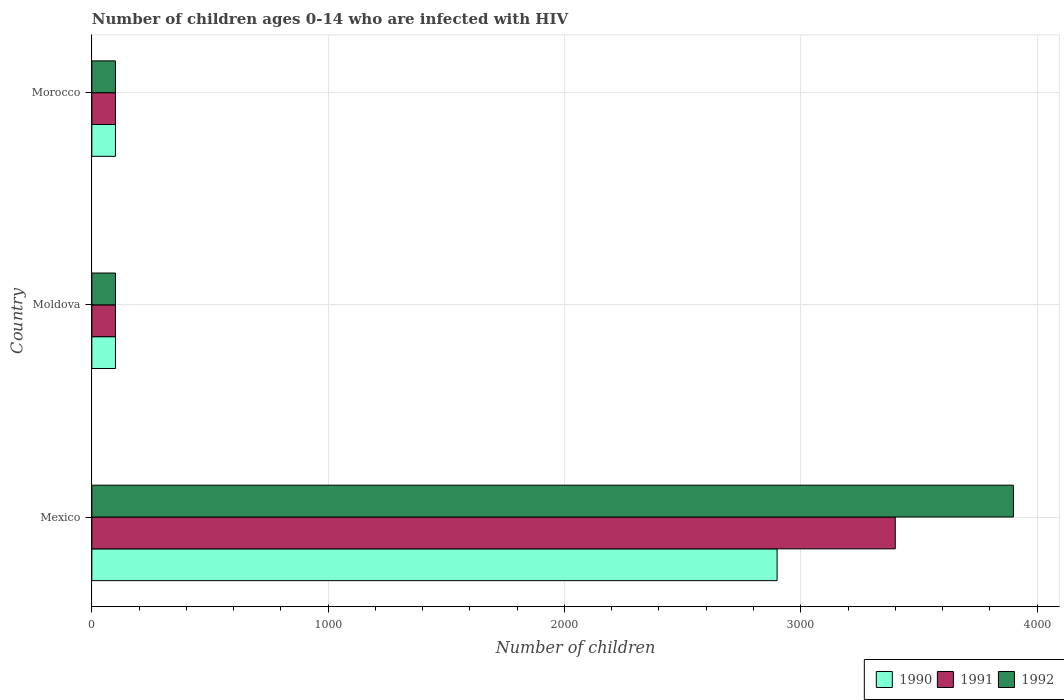How many different coloured bars are there?
Offer a terse response. 3. How many groups of bars are there?
Offer a very short reply. 3. Are the number of bars on each tick of the Y-axis equal?
Make the answer very short. Yes. How many bars are there on the 3rd tick from the top?
Give a very brief answer. 3. In how many cases, is the number of bars for a given country not equal to the number of legend labels?
Provide a short and direct response. 0. What is the number of HIV infected children in 1992 in Morocco?
Offer a terse response. 100. Across all countries, what is the maximum number of HIV infected children in 1991?
Offer a very short reply. 3400. Across all countries, what is the minimum number of HIV infected children in 1991?
Your response must be concise. 100. In which country was the number of HIV infected children in 1992 maximum?
Your answer should be very brief. Mexico. In which country was the number of HIV infected children in 1990 minimum?
Keep it short and to the point. Moldova. What is the total number of HIV infected children in 1991 in the graph?
Your answer should be very brief. 3600. What is the difference between the number of HIV infected children in 1992 in Mexico and that in Moldova?
Offer a very short reply. 3800. What is the difference between the number of HIV infected children in 1990 in Morocco and the number of HIV infected children in 1992 in Mexico?
Offer a terse response. -3800. What is the average number of HIV infected children in 1990 per country?
Provide a short and direct response. 1033.33. What is the difference between the number of HIV infected children in 1992 and number of HIV infected children in 1991 in Mexico?
Your answer should be compact. 500. In how many countries, is the number of HIV infected children in 1992 greater than 2400 ?
Your answer should be compact. 1. Is the number of HIV infected children in 1990 in Mexico less than that in Moldova?
Offer a terse response. No. What is the difference between the highest and the second highest number of HIV infected children in 1990?
Your answer should be compact. 2800. What is the difference between the highest and the lowest number of HIV infected children in 1990?
Offer a very short reply. 2800. What does the 2nd bar from the bottom in Moldova represents?
Your answer should be compact. 1991. Where does the legend appear in the graph?
Provide a short and direct response. Bottom right. How are the legend labels stacked?
Provide a short and direct response. Horizontal. What is the title of the graph?
Provide a short and direct response. Number of children ages 0-14 who are infected with HIV. What is the label or title of the X-axis?
Provide a short and direct response. Number of children. What is the label or title of the Y-axis?
Provide a short and direct response. Country. What is the Number of children of 1990 in Mexico?
Your response must be concise. 2900. What is the Number of children of 1991 in Mexico?
Offer a terse response. 3400. What is the Number of children in 1992 in Mexico?
Keep it short and to the point. 3900. What is the Number of children of 1990 in Moldova?
Offer a terse response. 100. What is the Number of children of 1991 in Moldova?
Offer a terse response. 100. What is the Number of children of 1992 in Moldova?
Give a very brief answer. 100. What is the Number of children in 1990 in Morocco?
Your response must be concise. 100. What is the Number of children in 1992 in Morocco?
Give a very brief answer. 100. Across all countries, what is the maximum Number of children in 1990?
Your answer should be very brief. 2900. Across all countries, what is the maximum Number of children of 1991?
Give a very brief answer. 3400. Across all countries, what is the maximum Number of children in 1992?
Provide a succinct answer. 3900. Across all countries, what is the minimum Number of children in 1990?
Provide a succinct answer. 100. Across all countries, what is the minimum Number of children in 1991?
Make the answer very short. 100. Across all countries, what is the minimum Number of children in 1992?
Offer a terse response. 100. What is the total Number of children of 1990 in the graph?
Make the answer very short. 3100. What is the total Number of children in 1991 in the graph?
Your answer should be compact. 3600. What is the total Number of children in 1992 in the graph?
Your answer should be compact. 4100. What is the difference between the Number of children in 1990 in Mexico and that in Moldova?
Provide a succinct answer. 2800. What is the difference between the Number of children in 1991 in Mexico and that in Moldova?
Keep it short and to the point. 3300. What is the difference between the Number of children in 1992 in Mexico and that in Moldova?
Your answer should be very brief. 3800. What is the difference between the Number of children of 1990 in Mexico and that in Morocco?
Provide a short and direct response. 2800. What is the difference between the Number of children of 1991 in Mexico and that in Morocco?
Make the answer very short. 3300. What is the difference between the Number of children of 1992 in Mexico and that in Morocco?
Provide a short and direct response. 3800. What is the difference between the Number of children of 1991 in Moldova and that in Morocco?
Offer a terse response. 0. What is the difference between the Number of children in 1992 in Moldova and that in Morocco?
Give a very brief answer. 0. What is the difference between the Number of children in 1990 in Mexico and the Number of children in 1991 in Moldova?
Your answer should be very brief. 2800. What is the difference between the Number of children in 1990 in Mexico and the Number of children in 1992 in Moldova?
Ensure brevity in your answer.  2800. What is the difference between the Number of children of 1991 in Mexico and the Number of children of 1992 in Moldova?
Give a very brief answer. 3300. What is the difference between the Number of children in 1990 in Mexico and the Number of children in 1991 in Morocco?
Offer a very short reply. 2800. What is the difference between the Number of children of 1990 in Mexico and the Number of children of 1992 in Morocco?
Ensure brevity in your answer.  2800. What is the difference between the Number of children of 1991 in Mexico and the Number of children of 1992 in Morocco?
Keep it short and to the point. 3300. What is the difference between the Number of children of 1991 in Moldova and the Number of children of 1992 in Morocco?
Give a very brief answer. 0. What is the average Number of children of 1990 per country?
Offer a very short reply. 1033.33. What is the average Number of children of 1991 per country?
Keep it short and to the point. 1200. What is the average Number of children of 1992 per country?
Your answer should be compact. 1366.67. What is the difference between the Number of children in 1990 and Number of children in 1991 in Mexico?
Provide a short and direct response. -500. What is the difference between the Number of children in 1990 and Number of children in 1992 in Mexico?
Your response must be concise. -1000. What is the difference between the Number of children of 1991 and Number of children of 1992 in Mexico?
Offer a terse response. -500. What is the difference between the Number of children of 1990 and Number of children of 1991 in Moldova?
Your answer should be compact. 0. What is the difference between the Number of children of 1990 and Number of children of 1992 in Moldova?
Offer a terse response. 0. What is the difference between the Number of children of 1991 and Number of children of 1992 in Moldova?
Give a very brief answer. 0. What is the difference between the Number of children of 1990 and Number of children of 1991 in Morocco?
Give a very brief answer. 0. What is the difference between the Number of children of 1990 and Number of children of 1992 in Morocco?
Offer a terse response. 0. What is the difference between the Number of children in 1991 and Number of children in 1992 in Morocco?
Provide a short and direct response. 0. What is the ratio of the Number of children of 1990 in Mexico to that in Moldova?
Offer a very short reply. 29. What is the ratio of the Number of children of 1991 in Mexico to that in Moldova?
Make the answer very short. 34. What is the ratio of the Number of children in 1992 in Mexico to that in Morocco?
Your answer should be compact. 39. What is the ratio of the Number of children in 1991 in Moldova to that in Morocco?
Offer a very short reply. 1. What is the ratio of the Number of children in 1992 in Moldova to that in Morocco?
Your answer should be very brief. 1. What is the difference between the highest and the second highest Number of children of 1990?
Offer a very short reply. 2800. What is the difference between the highest and the second highest Number of children of 1991?
Offer a very short reply. 3300. What is the difference between the highest and the second highest Number of children of 1992?
Offer a terse response. 3800. What is the difference between the highest and the lowest Number of children of 1990?
Give a very brief answer. 2800. What is the difference between the highest and the lowest Number of children of 1991?
Give a very brief answer. 3300. What is the difference between the highest and the lowest Number of children in 1992?
Provide a succinct answer. 3800. 